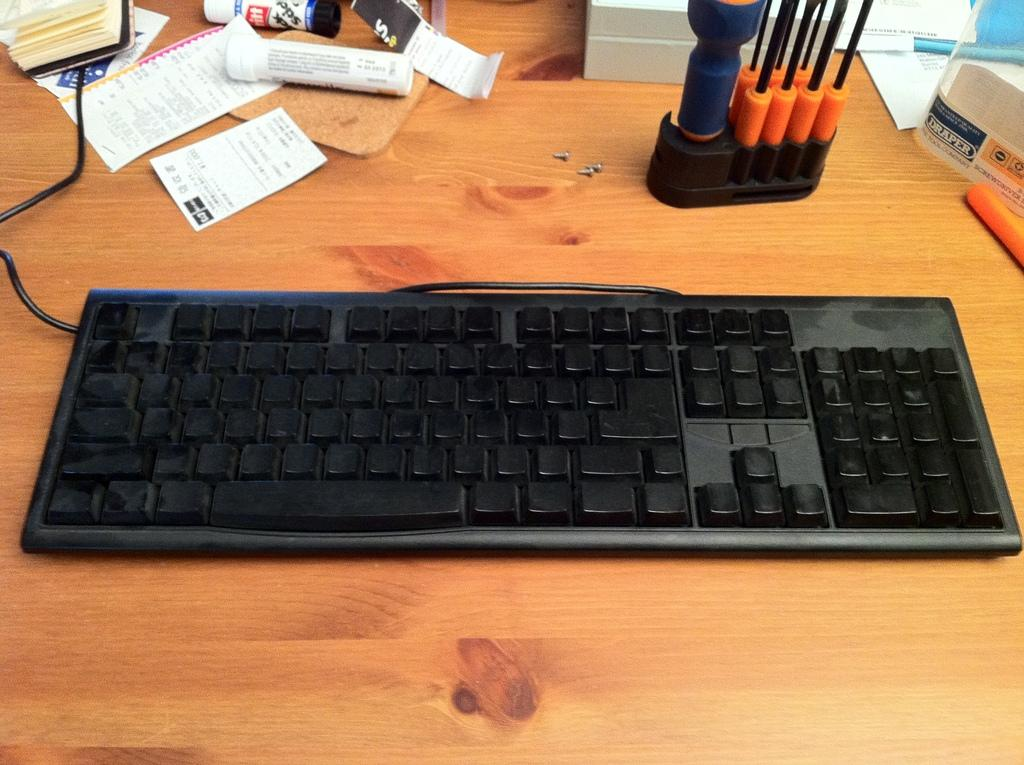<image>
Give a short and clear explanation of the subsequent image. The label for a product from Draper is visible at the edge of a desktop. 